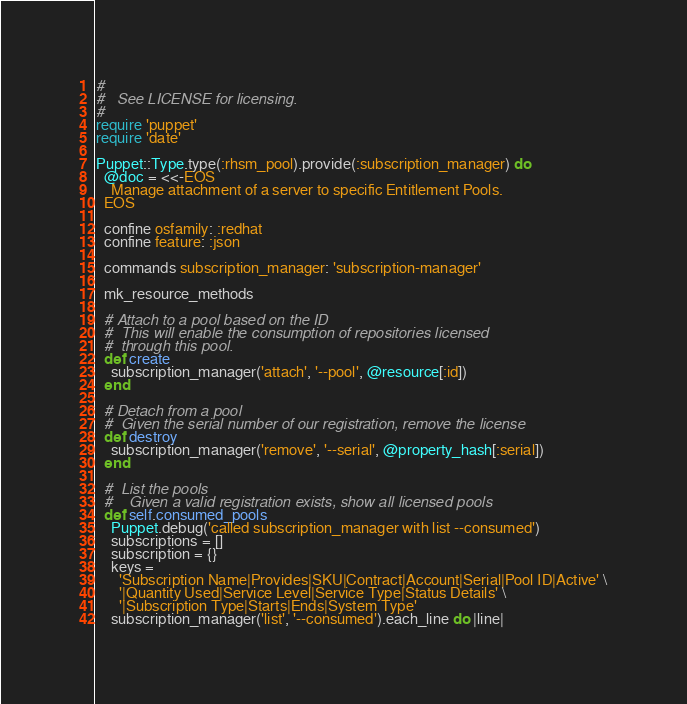<code> <loc_0><loc_0><loc_500><loc_500><_Ruby_>#
#   See LICENSE for licensing.
#
require 'puppet'
require 'date'

Puppet::Type.type(:rhsm_pool).provide(:subscription_manager) do
  @doc = <<-EOS
    Manage attachment of a server to specific Entitlement Pools.
  EOS

  confine osfamily: :redhat
  confine feature: :json

  commands subscription_manager: 'subscription-manager'

  mk_resource_methods

  # Attach to a pool based on the ID
  #  This will enable the consumption of repositories licensed
  #  through this pool.
  def create
    subscription_manager('attach', '--pool', @resource[:id])
  end

  # Detach from a pool
  #  Given the serial number of our registration, remove the license
  def destroy
    subscription_manager('remove', '--serial', @property_hash[:serial])
  end

  #  List the pools
  #    Given a valid registration exists, show all licensed pools
  def self.consumed_pools
    Puppet.debug('called subscription_manager with list --consumed')
    subscriptions = []
    subscription = {}
    keys =
      'Subscription Name|Provides|SKU|Contract|Account|Serial|Pool ID|Active' \
      '|Quantity Used|Service Level|Service Type|Status Details' \
      '|Subscription Type|Starts|Ends|System Type'
    subscription_manager('list', '--consumed').each_line do |line|</code> 